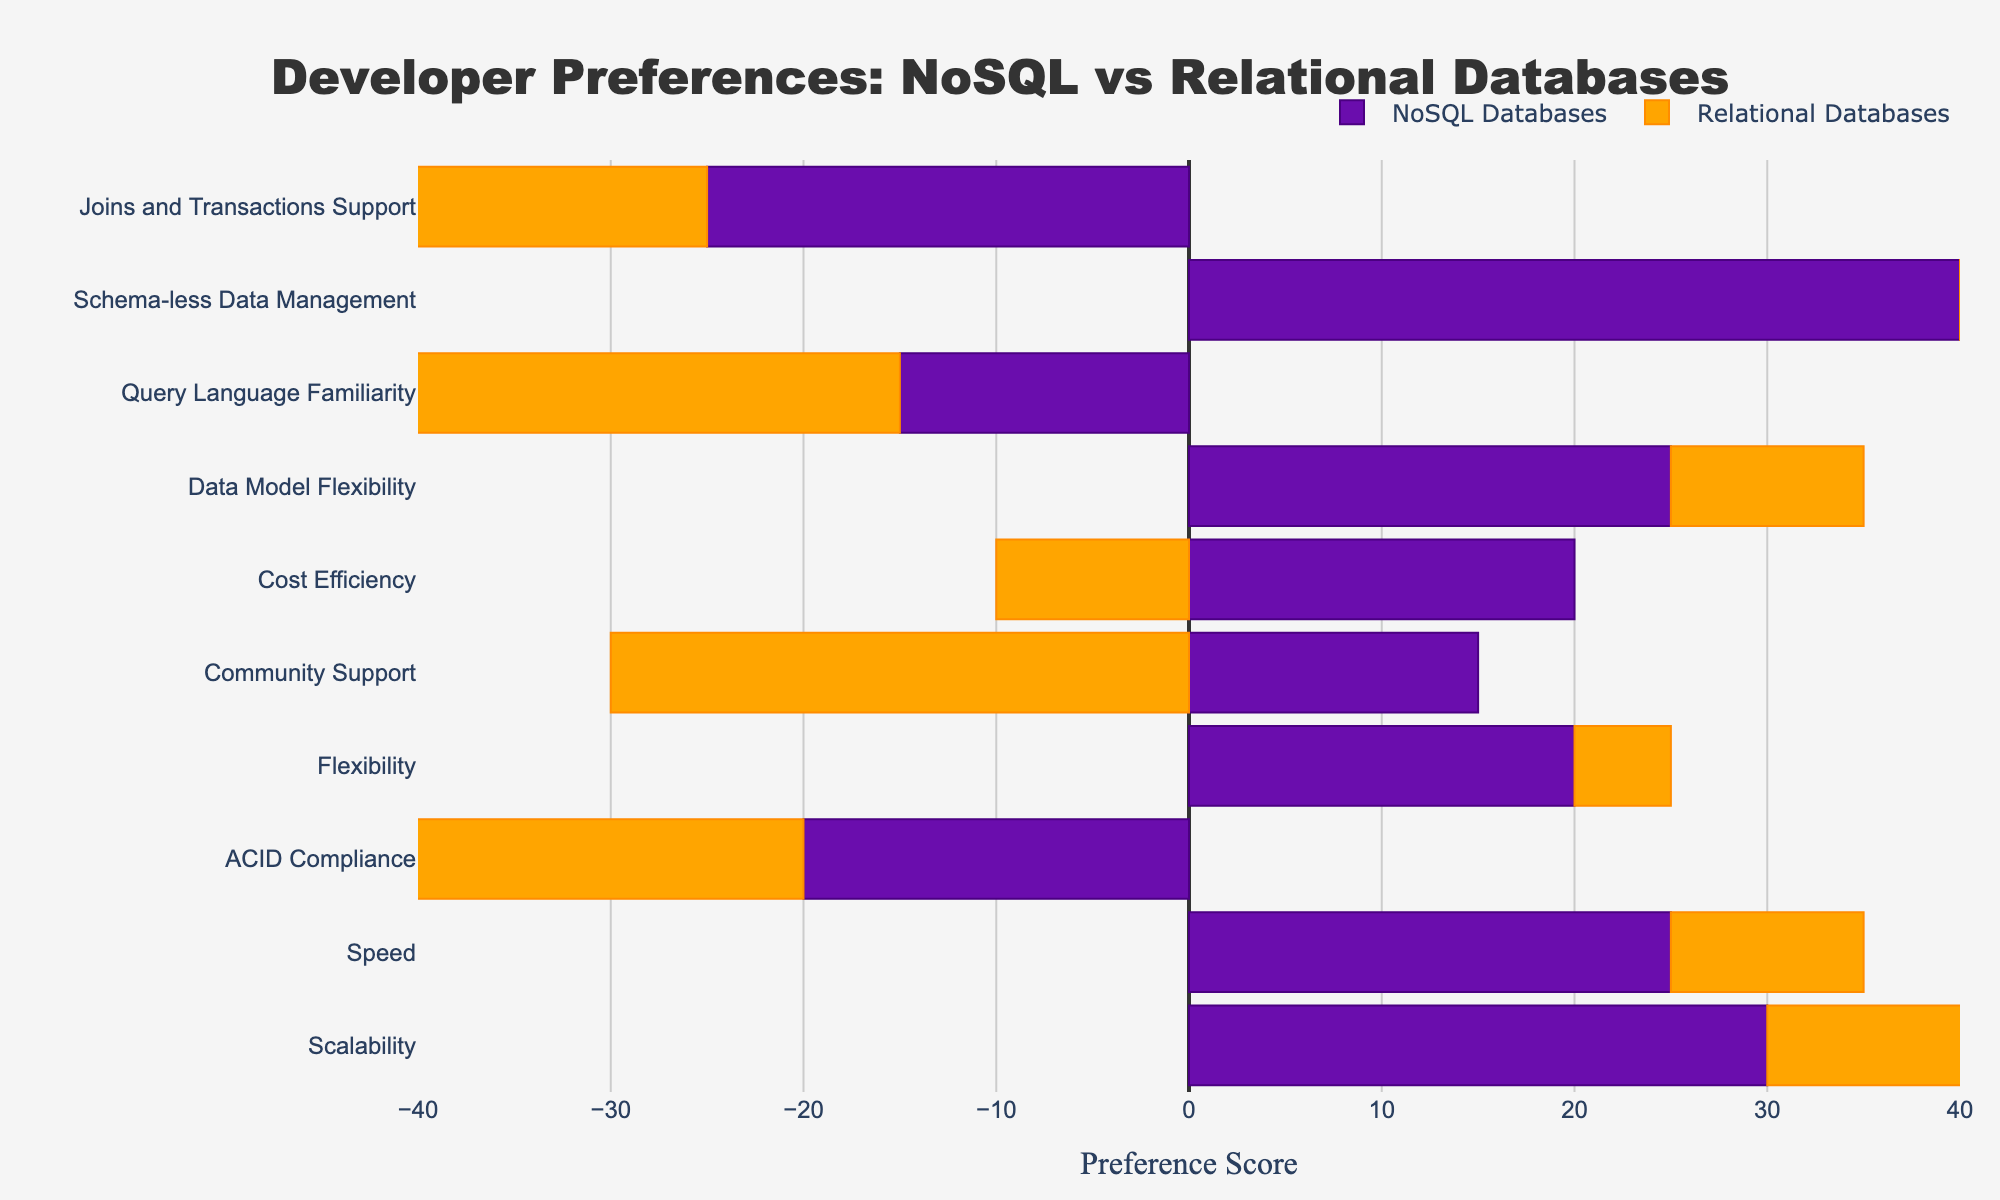Which feature has the highest preference score for NoSQL Databases? By looking at the length of the bars in the NoSQL Databases section, the longest bar corresponds to "Schema-less Data Management" with a score of 40.
Answer: Schema-less Data Management What is the difference in preference score for "ACID Compliance" between Relational Databases and NoSQL Databases? For "ACID Compliance," Relational Databases have a score of 35, while NoSQL Databases have -20. The difference is calculated as 35 - (-20) = 55.
Answer: 55 Which database type has a higher preference score for "Community Support," and by how much? Relational Databases have a score of 30 for "Community Support," and NoSQL Databases have a score of 15. The difference is 30 - 15 = 15.
Answer: Relational Databases, 15 What is the sum of preference scores for "Flexibility" and "Cost Efficiency" for NoSQL Databases? The preference scores for "Flexibility" and "Cost Efficiency" for NoSQL Databases are 20 and 20 respectively. Sum them up: 20 + 20 = 40.
Answer: 40 Which feature shows the greatest negative preference score for Relational Databases? By examining the bars for Relational Databases, the feature "Scalability" has the largest negative value of -15.
Answer: Scalability How many features have a higher preference score for NoSQL Databases compared to Relational Databases? By comparing the bars for each feature, "Scalability," "Speed," "Flexibility," "Cost Efficiency," "Data Model Flexibility," and "Schema-less Data Management" have higher scores for NoSQL Databases. Counting these features, we get 6.
Answer: 6 What are the combined preference scores for "Speed" and "Data Model Flexibility" for Relational Databases? The preference scores for "Speed" and "Data Model Flexibility" for Relational Databases are -10 and -10 respectively. Summing them up: -10 + (-10) = -20.
Answer: -20 